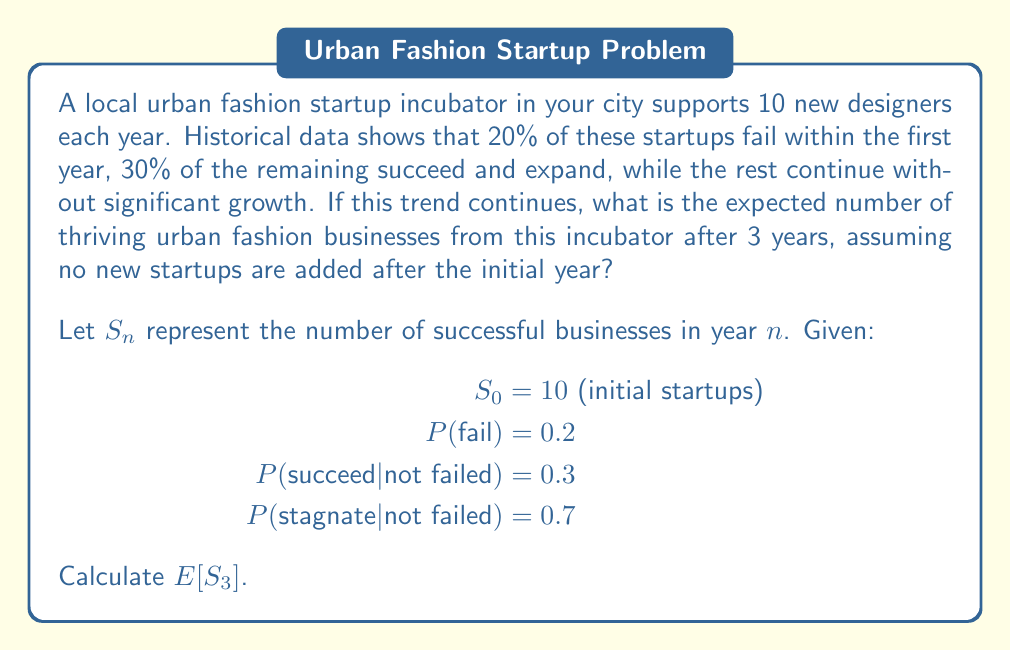What is the answer to this math problem? Let's approach this step-by-step:

1) First, let's calculate the probabilities for each year:
   $P(\text{survive}) = 1 - P(\text{fail}) = 1 - 0.2 = 0.8$
   $P(\text{succeed}) = P(\text{survive}) \times P(\text{succeed}|\text{not failed}) = 0.8 \times 0.3 = 0.24$
   $P(\text{stagnate}) = P(\text{survive}) \times P(\text{stagnate}|\text{not failed}) = 0.8 \times 0.7 = 0.56$

2) Now, let's calculate the expected number of businesses in each category after year 1:
   $E[\text{Failed}_{1}] = 10 \times 0.2 = 2$
   $E[\text{Succeeded}_{1}] = 10 \times 0.24 = 2.4$
   $E[\text{Stagnated}_{1}] = 10 \times 0.56 = 5.6$

3) For year 2, only the stagnated businesses from year 1 are at risk:
   $E[\text{Failed}_{2}] = 5.6 \times 0.2 = 1.12$
   $E[\text{Succeeded}_{2}] = 5.6 \times 0.24 = 1.344$
   $E[\text{Stagnated}_{2}] = 5.6 \times 0.56 = 3.136$

4) For year 3, only the stagnated businesses from year 2 are at risk:
   $E[\text{Failed}_{3}] = 3.136 \times 0.2 = 0.6272$
   $E[\text{Succeeded}_{3}] = 3.136 \times 0.24 = 0.75264$
   $E[\text{Stagnated}_{3}] = 3.136 \times 0.56 = 1.75616$

5) The total number of thriving businesses after 3 years is the sum of all succeeded businesses over the 3 years plus those that stagnated in year 3:
   $E[S_3] = 2.4 + 1.344 + 0.75264 + 1.75616 = 6.2528$
Answer: 6.2528 